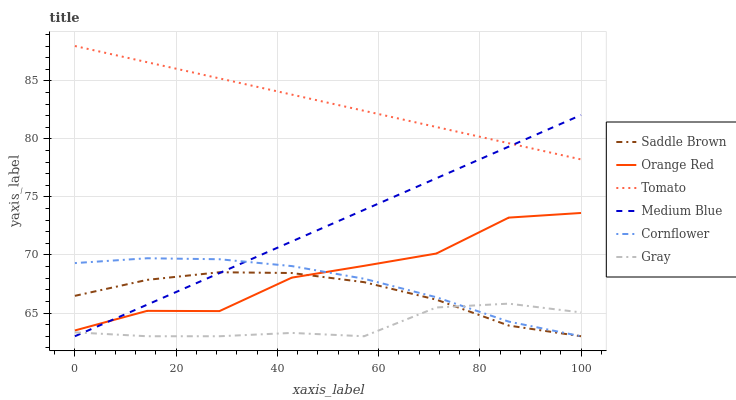Does Gray have the minimum area under the curve?
Answer yes or no. Yes. Does Tomato have the maximum area under the curve?
Answer yes or no. Yes. Does Cornflower have the minimum area under the curve?
Answer yes or no. No. Does Cornflower have the maximum area under the curve?
Answer yes or no. No. Is Tomato the smoothest?
Answer yes or no. Yes. Is Orange Red the roughest?
Answer yes or no. Yes. Is Cornflower the smoothest?
Answer yes or no. No. Is Cornflower the roughest?
Answer yes or no. No. Does Cornflower have the lowest value?
Answer yes or no. Yes. Does Orange Red have the lowest value?
Answer yes or no. No. Does Tomato have the highest value?
Answer yes or no. Yes. Does Cornflower have the highest value?
Answer yes or no. No. Is Gray less than Tomato?
Answer yes or no. Yes. Is Tomato greater than Orange Red?
Answer yes or no. Yes. Does Saddle Brown intersect Gray?
Answer yes or no. Yes. Is Saddle Brown less than Gray?
Answer yes or no. No. Is Saddle Brown greater than Gray?
Answer yes or no. No. Does Gray intersect Tomato?
Answer yes or no. No. 